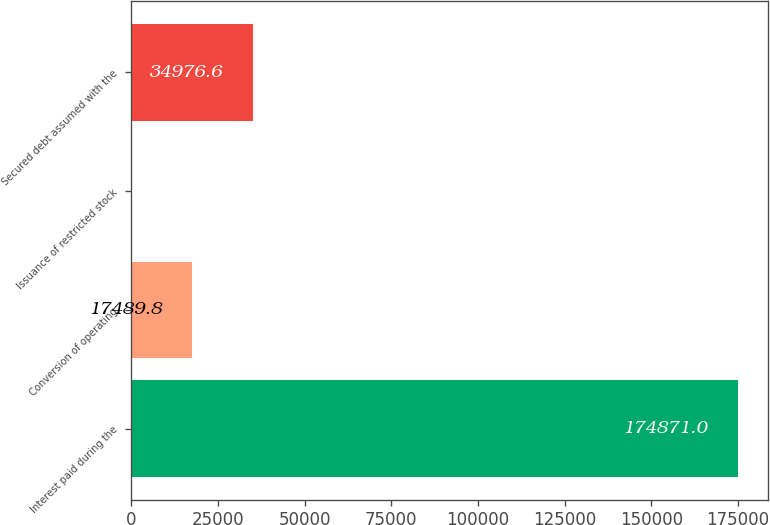<chart> <loc_0><loc_0><loc_500><loc_500><bar_chart><fcel>Interest paid during the<fcel>Conversion of operating<fcel>Issuance of restricted stock<fcel>Secured debt assumed with the<nl><fcel>174871<fcel>17489.8<fcel>3<fcel>34976.6<nl></chart> 